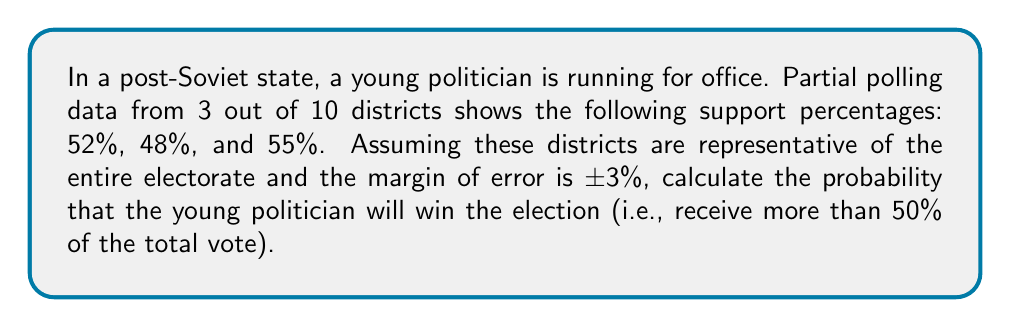Give your solution to this math problem. Let's approach this step-by-step:

1) First, we need to calculate the mean support percentage from the available data:
   $\mu = \frac{52\% + 48\% + 55\%}{3} = 51.67\%$

2) We're told the margin of error is ±3%. In statistical terms, this typically refers to a 95% confidence interval. For a normal distribution, this means the standard error (SE) is half of this:
   $SE = \frac{3\%}{2} = 1.5\%$

3) We can model the true population mean as a normal distribution with:
   $\mu = 51.67\%$ and $\sigma = 1.5\%$

4) To win, the politician needs more than 50% of the vote. We need to find the probability that the true population mean is greater than 50%.

5) We can calculate the z-score for 50%:
   $z = \frac{50\% - 51.67\%}{1.5\%} = -1.11$

6) The probability of winning is the area to the right of z = -1.11 in a standard normal distribution.

7) Using a standard normal table or calculator, we find:
   $P(Z > -1.11) = 1 - P(Z < -1.11) = 1 - 0.1335 = 0.8665$

Therefore, the probability of the young politician winning the election is approximately 0.8665 or 86.65%.
Answer: 86.65% 